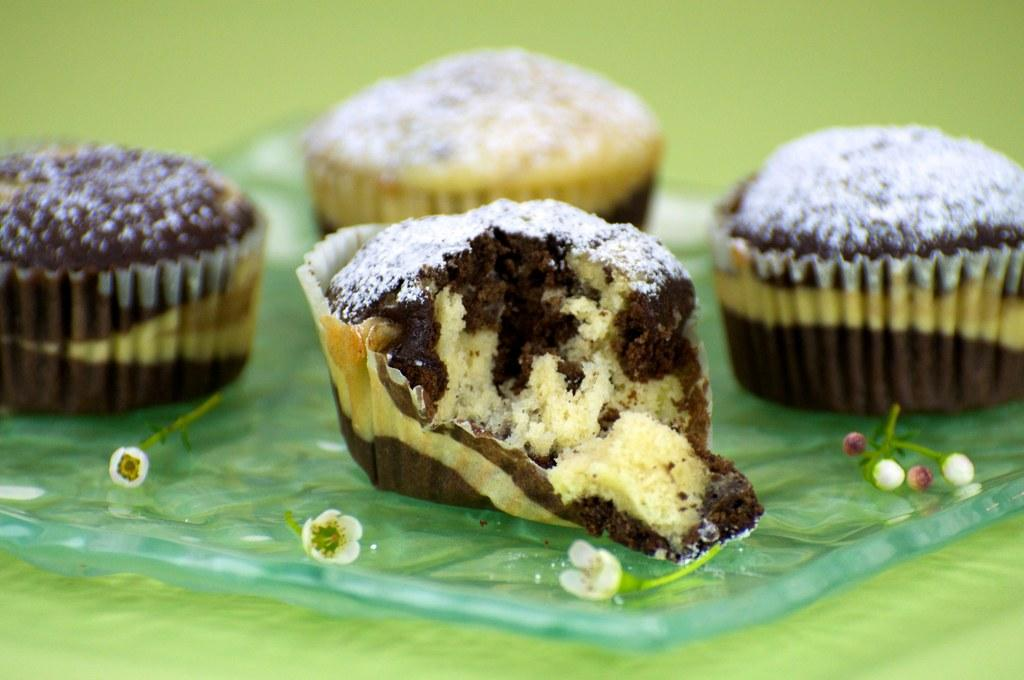What type of flora is present in the image? There are tiny flowers in the image. How many cupcakes can be seen in the image? There are four cupcakes in the image. Can you describe the condition of one of the cupcakes? One of the cupcakes is half eaten. What color is the background of the image? The background of the image is green in color. What type of tool is the carpenter using to fix the drum in the image? There is no carpenter, drum, or tool present in the image. What type of patch is visible on the cupcake in the image? There is no patch visible on any of the cupcakes in the image. 